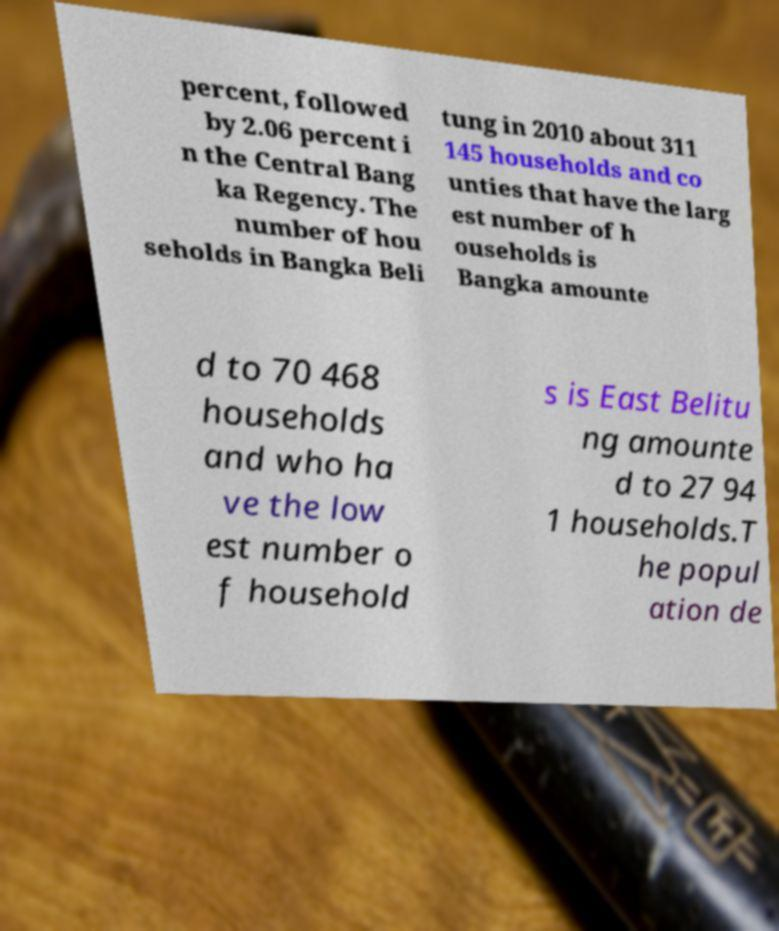I need the written content from this picture converted into text. Can you do that? percent, followed by 2.06 percent i n the Central Bang ka Regency. The number of hou seholds in Bangka Beli tung in 2010 about 311 145 households and co unties that have the larg est number of h ouseholds is Bangka amounte d to 70 468 households and who ha ve the low est number o f household s is East Belitu ng amounte d to 27 94 1 households.T he popul ation de 